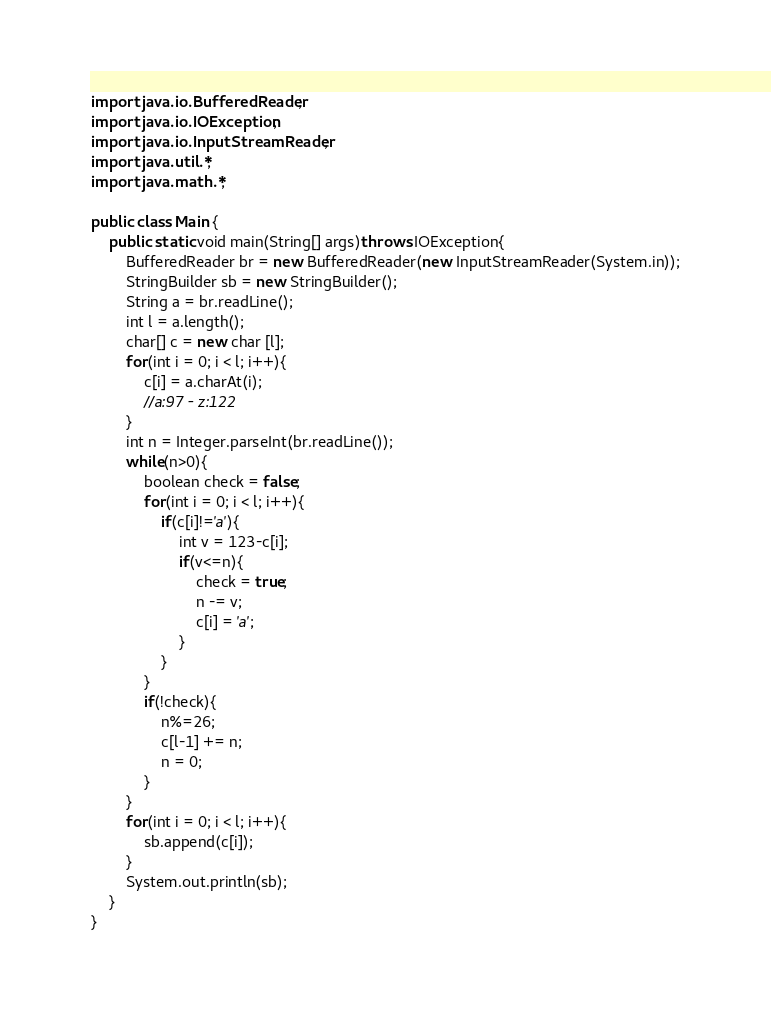<code> <loc_0><loc_0><loc_500><loc_500><_Java_>import java.io.BufferedReader;
import java.io.IOException;
import java.io.InputStreamReader;
import java.util.*;
import java.math.*;
 
public class Main {
	public static void main(String[] args)throws IOException{
		BufferedReader br = new BufferedReader(new InputStreamReader(System.in));
		StringBuilder sb = new StringBuilder();
		String a = br.readLine();
		int l = a.length();
		char[] c = new char [l];
		for(int i = 0; i < l; i++){
			c[i] = a.charAt(i);
			//a:97 - z:122
		}
		int n = Integer.parseInt(br.readLine());
		while(n>0){
			boolean check = false;
			for(int i = 0; i < l; i++){
				if(c[i]!='a'){
					int v = 123-c[i];
					if(v<=n){
						check = true;
						n -= v;
						c[i] = 'a';
					}
				}
			}
			if(!check){
				n%=26;
				c[l-1] += n;
				n = 0;
			}
		}
		for(int i = 0; i < l; i++){
			sb.append(c[i]);
		}
		System.out.println(sb);
	}
}</code> 